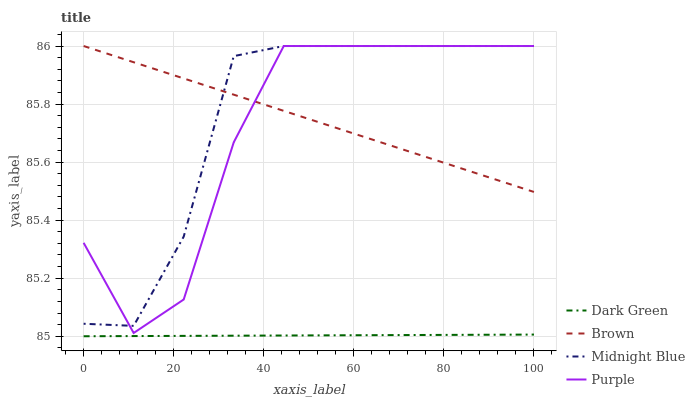Does Dark Green have the minimum area under the curve?
Answer yes or no. Yes. Does Midnight Blue have the maximum area under the curve?
Answer yes or no. Yes. Does Brown have the minimum area under the curve?
Answer yes or no. No. Does Brown have the maximum area under the curve?
Answer yes or no. No. Is Brown the smoothest?
Answer yes or no. Yes. Is Purple the roughest?
Answer yes or no. Yes. Is Midnight Blue the smoothest?
Answer yes or no. No. Is Midnight Blue the roughest?
Answer yes or no. No. Does Dark Green have the lowest value?
Answer yes or no. Yes. Does Midnight Blue have the lowest value?
Answer yes or no. No. Does Midnight Blue have the highest value?
Answer yes or no. Yes. Does Dark Green have the highest value?
Answer yes or no. No. Is Dark Green less than Brown?
Answer yes or no. Yes. Is Purple greater than Dark Green?
Answer yes or no. Yes. Does Midnight Blue intersect Purple?
Answer yes or no. Yes. Is Midnight Blue less than Purple?
Answer yes or no. No. Is Midnight Blue greater than Purple?
Answer yes or no. No. Does Dark Green intersect Brown?
Answer yes or no. No. 